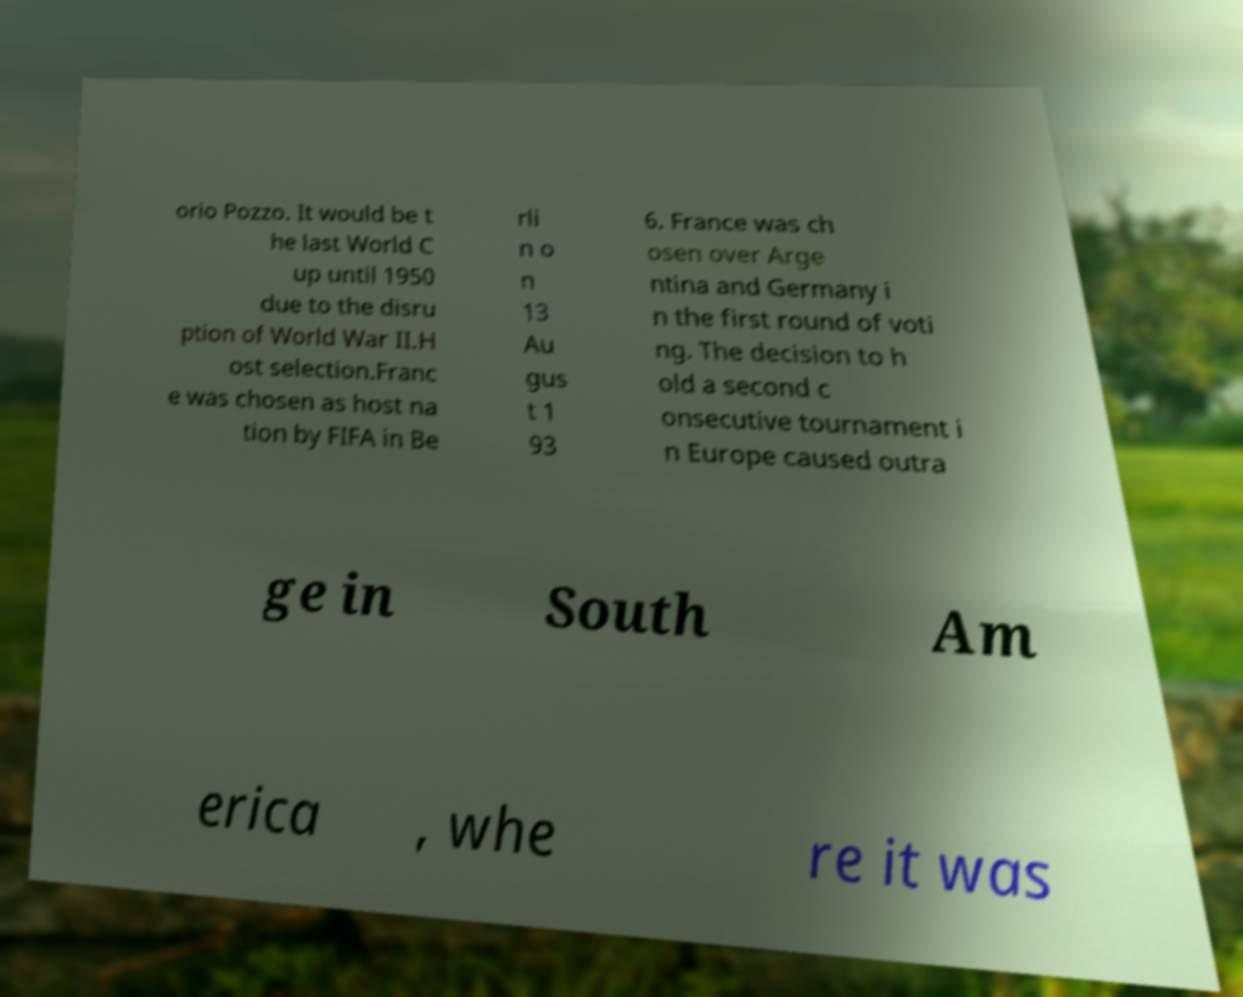What messages or text are displayed in this image? I need them in a readable, typed format. orio Pozzo. It would be t he last World C up until 1950 due to the disru ption of World War II.H ost selection.Franc e was chosen as host na tion by FIFA in Be rli n o n 13 Au gus t 1 93 6. France was ch osen over Arge ntina and Germany i n the first round of voti ng. The decision to h old a second c onsecutive tournament i n Europe caused outra ge in South Am erica , whe re it was 